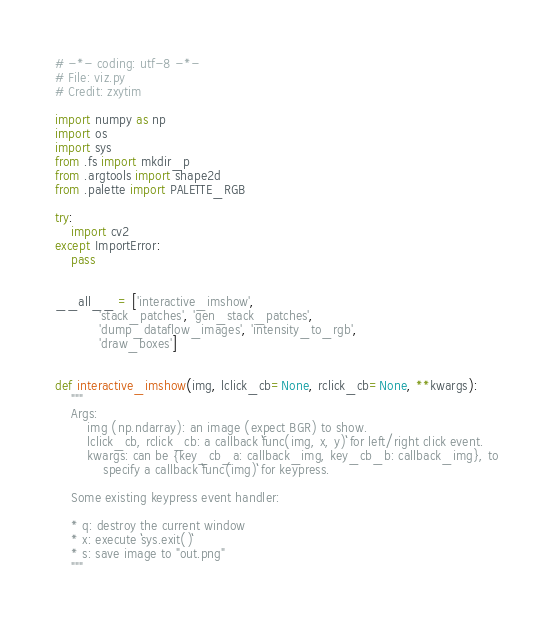Convert code to text. <code><loc_0><loc_0><loc_500><loc_500><_Python_># -*- coding: utf-8 -*-
# File: viz.py
# Credit: zxytim

import numpy as np
import os
import sys
from .fs import mkdir_p
from .argtools import shape2d
from .palette import PALETTE_RGB

try:
    import cv2
except ImportError:
    pass


__all__ = ['interactive_imshow',
           'stack_patches', 'gen_stack_patches',
           'dump_dataflow_images', 'intensity_to_rgb',
           'draw_boxes']


def interactive_imshow(img, lclick_cb=None, rclick_cb=None, **kwargs):
    """
    Args:
        img (np.ndarray): an image (expect BGR) to show.
        lclick_cb, rclick_cb: a callback ``func(img, x, y)`` for left/right click event.
        kwargs: can be {key_cb_a: callback_img, key_cb_b: callback_img}, to
            specify a callback ``func(img)`` for keypress.

    Some existing keypress event handler:

    * q: destroy the current window
    * x: execute ``sys.exit()``
    * s: save image to "out.png"
    """</code> 